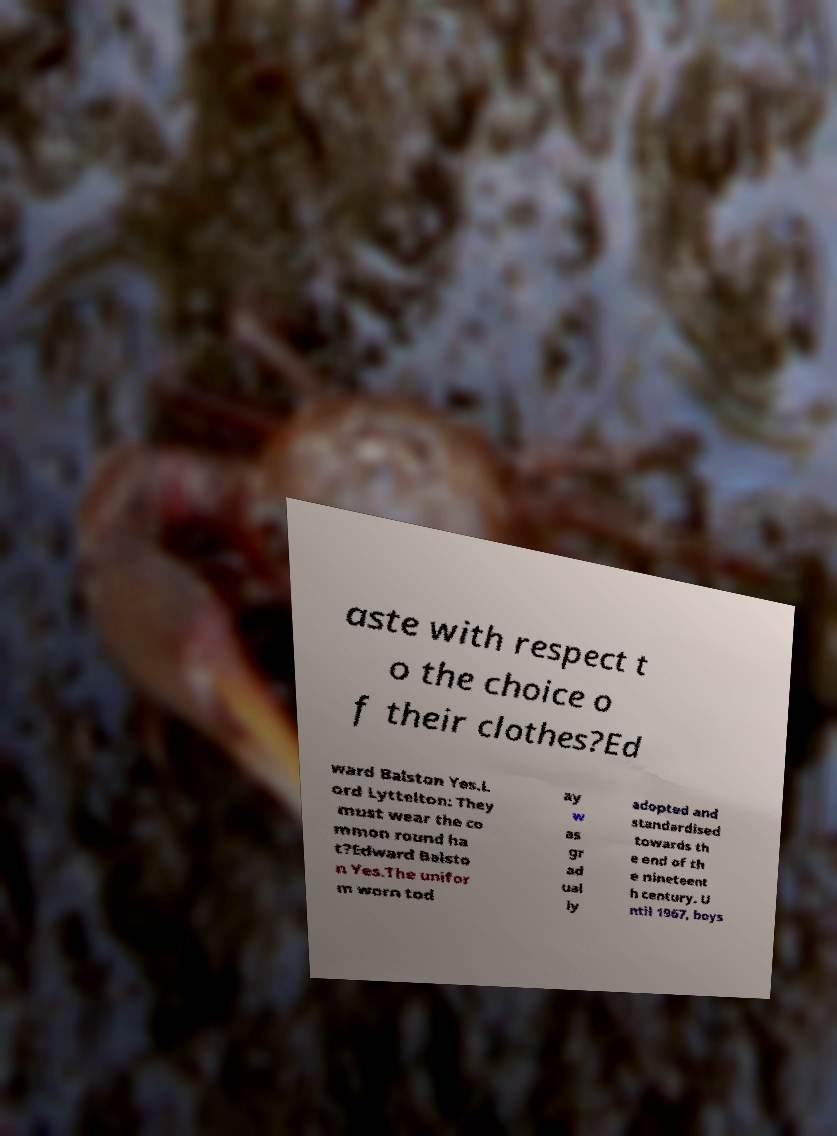What messages or text are displayed in this image? I need them in a readable, typed format. aste with respect t o the choice o f their clothes?Ed ward Balston Yes.L ord Lyttelton: They must wear the co mmon round ha t?Edward Balsto n Yes.The unifor m worn tod ay w as gr ad ual ly adopted and standardised towards th e end of th e nineteent h century. U ntil 1967, boys 